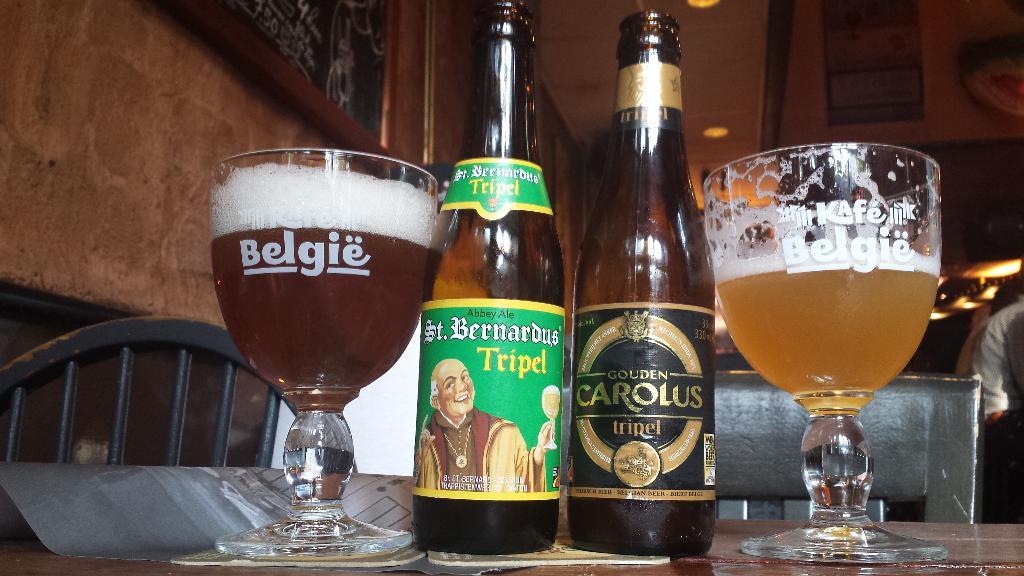What is the name of the beer on the left?
Your answer should be compact. Belgie. 